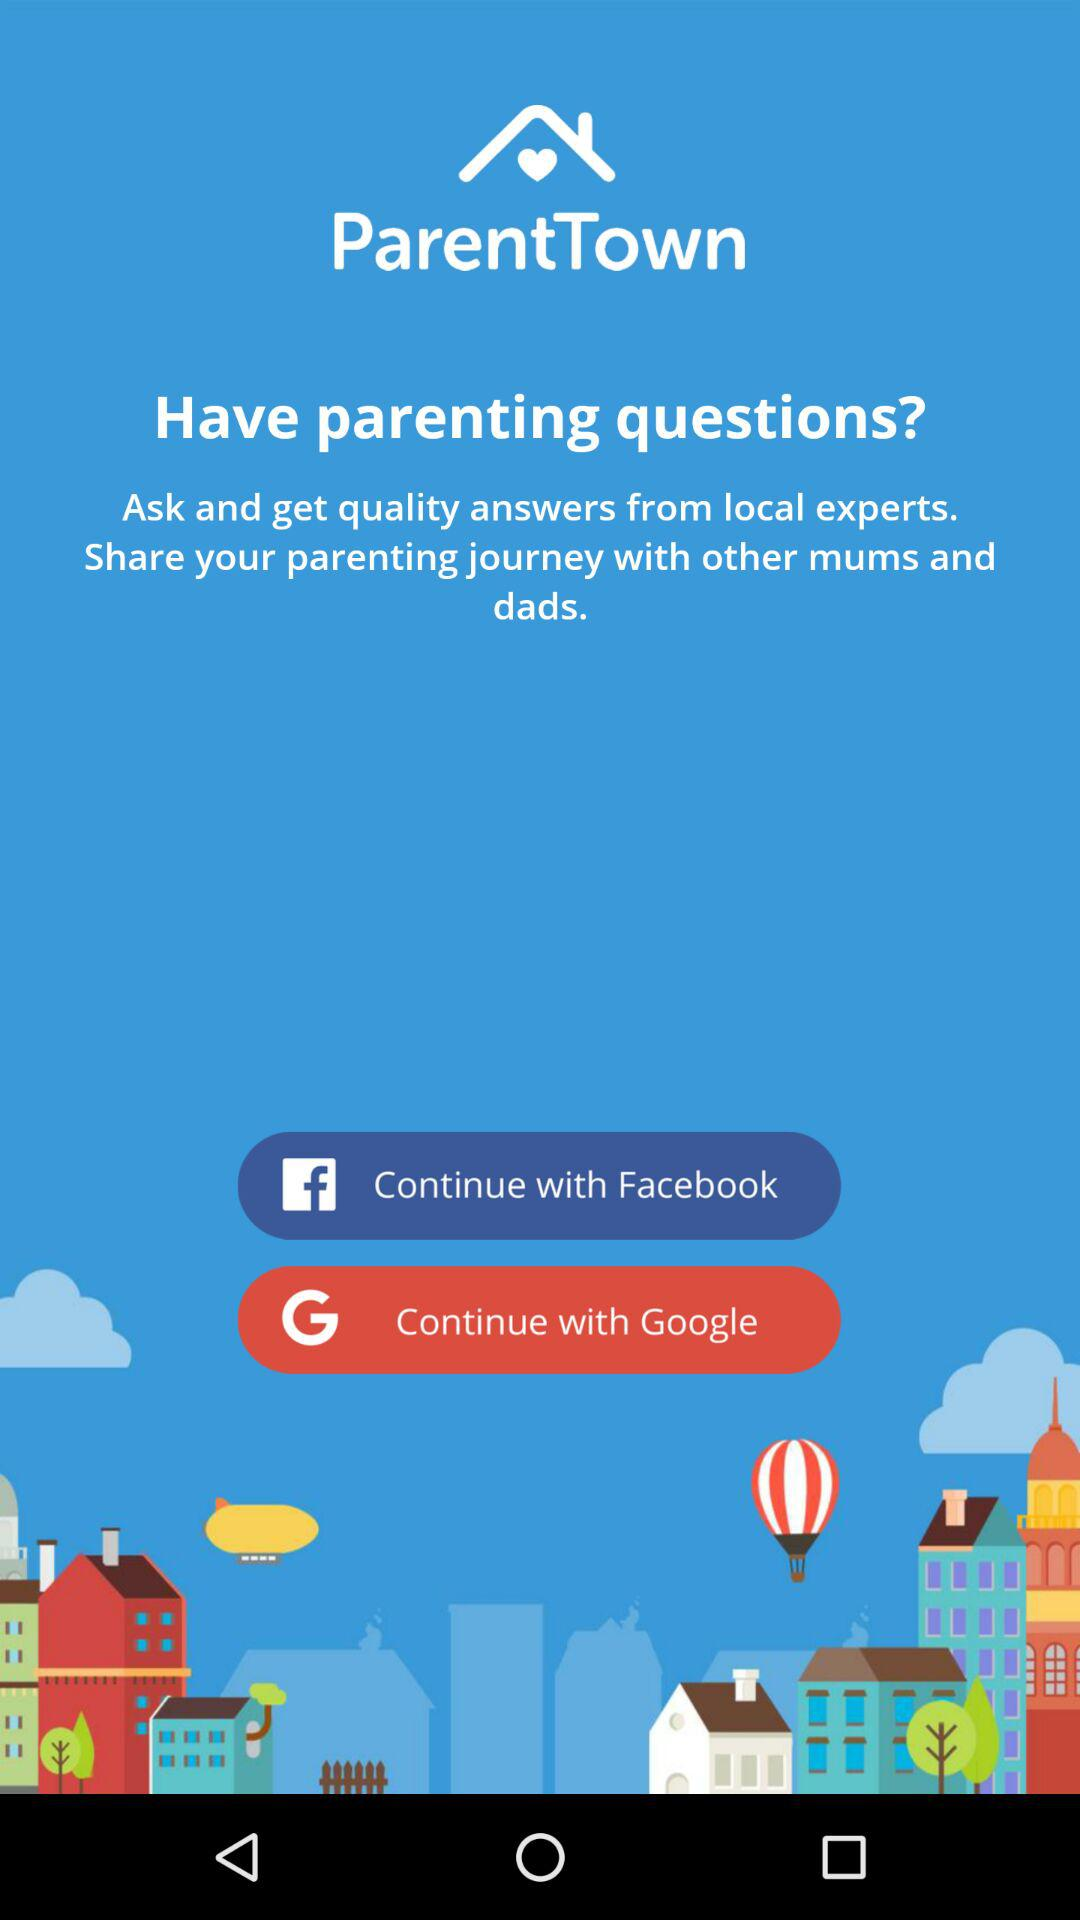What is the different login option? The different login options are "Facebook" and "Google". 